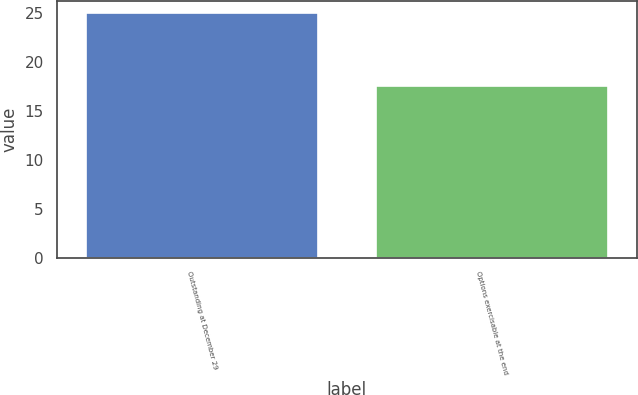<chart> <loc_0><loc_0><loc_500><loc_500><bar_chart><fcel>Outstanding at December 29<fcel>Options exercisable at the end<nl><fcel>24.94<fcel>17.51<nl></chart> 